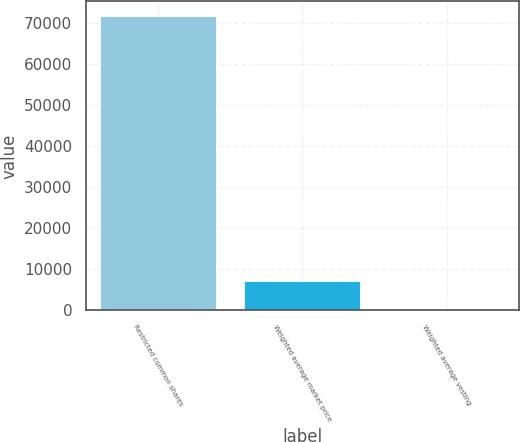Convert chart to OTSL. <chart><loc_0><loc_0><loc_500><loc_500><bar_chart><fcel>Restricted common shares<fcel>Weighted average market price<fcel>Weighted average vesting<nl><fcel>71752<fcel>7179.47<fcel>4.74<nl></chart> 